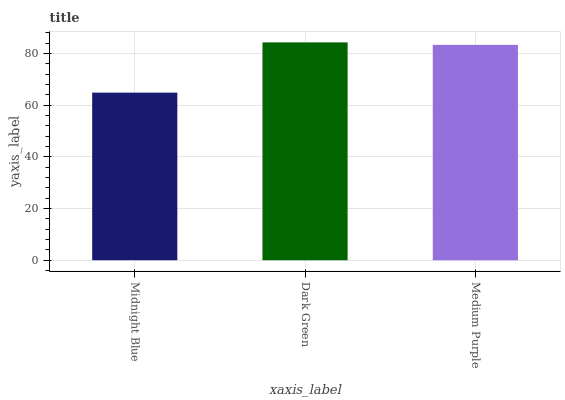Is Midnight Blue the minimum?
Answer yes or no. Yes. Is Dark Green the maximum?
Answer yes or no. Yes. Is Medium Purple the minimum?
Answer yes or no. No. Is Medium Purple the maximum?
Answer yes or no. No. Is Dark Green greater than Medium Purple?
Answer yes or no. Yes. Is Medium Purple less than Dark Green?
Answer yes or no. Yes. Is Medium Purple greater than Dark Green?
Answer yes or no. No. Is Dark Green less than Medium Purple?
Answer yes or no. No. Is Medium Purple the high median?
Answer yes or no. Yes. Is Medium Purple the low median?
Answer yes or no. Yes. Is Dark Green the high median?
Answer yes or no. No. Is Dark Green the low median?
Answer yes or no. No. 